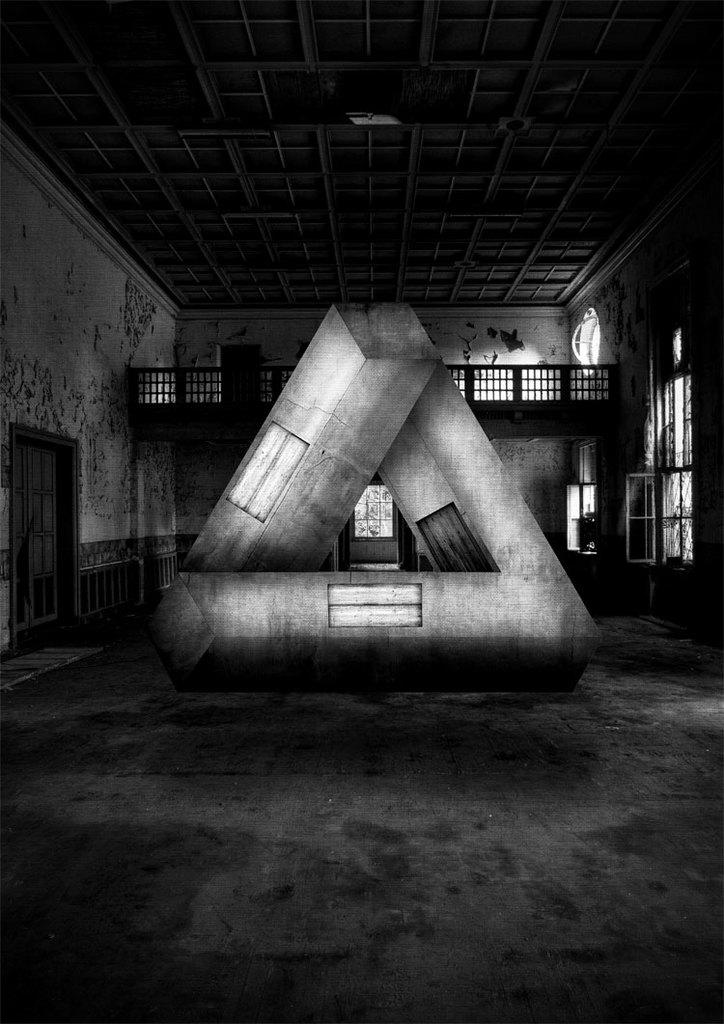What is the color scheme of the image? The image is black and white. What shape can be seen in the image? There is an object in the shape of a triangle in the image. What architectural features are present in the image? There is a door, a wall, windows, and a roof in the image. What is the name of the daughter who lives in the house in the image? There is no mention of a daughter or a house in the image; it only features a black and white triangle-shaped object and architectural elements. 